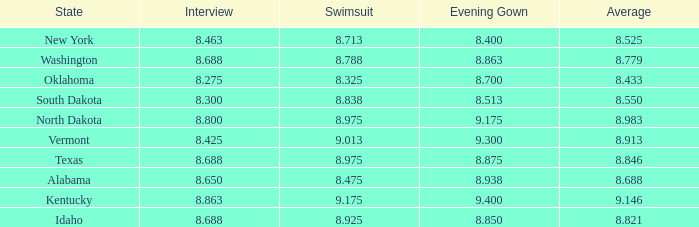Who had the lowest interview score from South Dakota with an evening gown less than 8.513? None. 